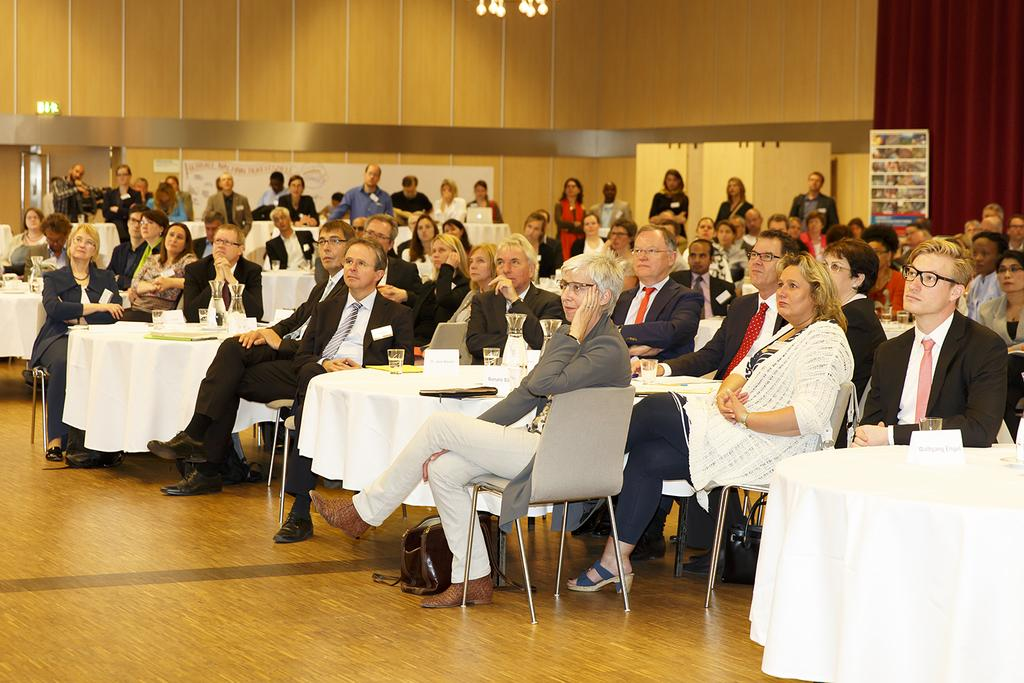How many people are in the image? The number of people in the image is not specified, but there are people present. What are the people doing in the image? The people are sitting in groups and listening to something. Where are the people sitting in the image? The people are sitting at tables in the image. What type of dirt can be seen on the floor in the image? There is no dirt visible on the floor in the image. What kind of lamp is providing light for the people in the image? There is no lamp present in the image; the people are listening to something, but the source of the sound is not specified. 